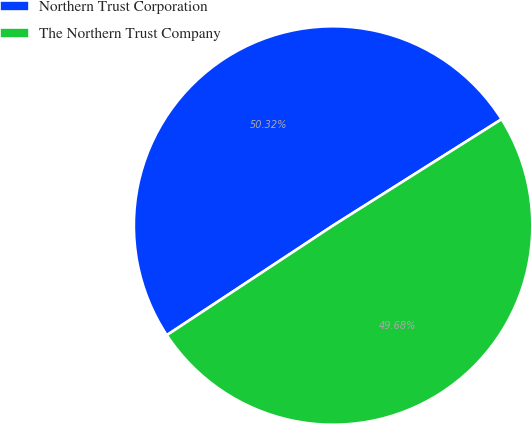<chart> <loc_0><loc_0><loc_500><loc_500><pie_chart><fcel>Northern Trust Corporation<fcel>The Northern Trust Company<nl><fcel>50.32%<fcel>49.68%<nl></chart> 